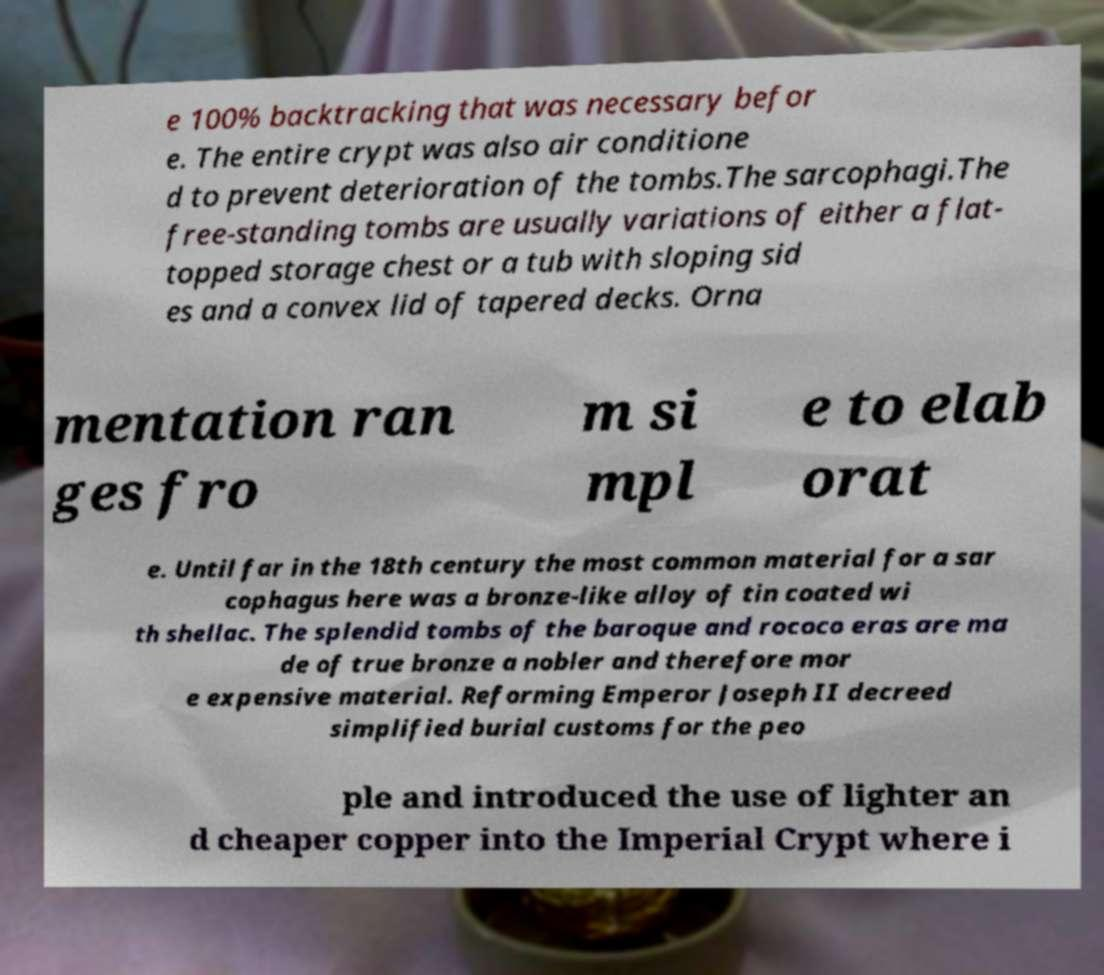Please identify and transcribe the text found in this image. e 100% backtracking that was necessary befor e. The entire crypt was also air conditione d to prevent deterioration of the tombs.The sarcophagi.The free-standing tombs are usually variations of either a flat- topped storage chest or a tub with sloping sid es and a convex lid of tapered decks. Orna mentation ran ges fro m si mpl e to elab orat e. Until far in the 18th century the most common material for a sar cophagus here was a bronze-like alloy of tin coated wi th shellac. The splendid tombs of the baroque and rococo eras are ma de of true bronze a nobler and therefore mor e expensive material. Reforming Emperor Joseph II decreed simplified burial customs for the peo ple and introduced the use of lighter an d cheaper copper into the Imperial Crypt where i 